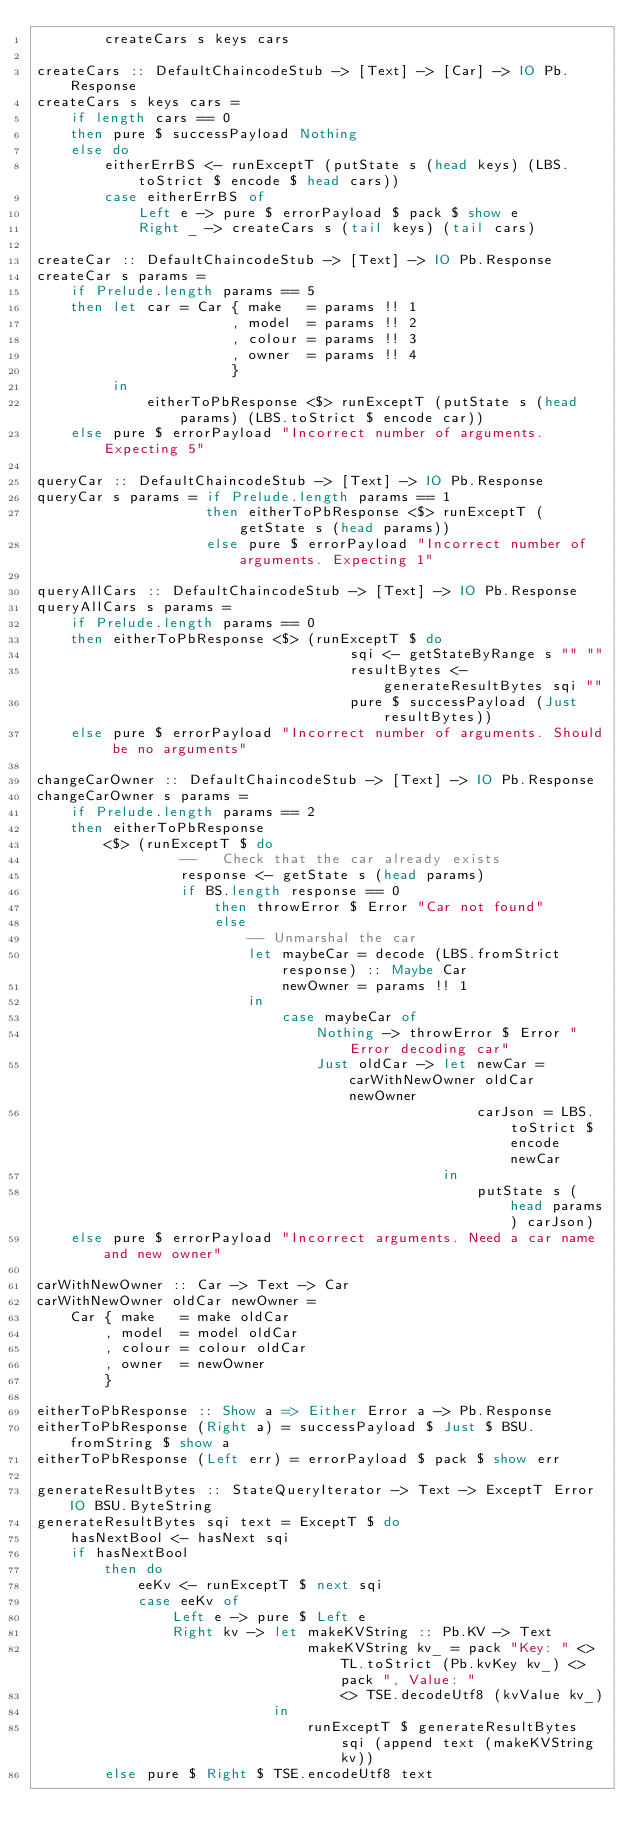Convert code to text. <code><loc_0><loc_0><loc_500><loc_500><_Haskell_>        createCars s keys cars

createCars :: DefaultChaincodeStub -> [Text] -> [Car] -> IO Pb.Response
createCars s keys cars =
    if length cars == 0
    then pure $ successPayload Nothing
    else do
        eitherErrBS <- runExceptT (putState s (head keys) (LBS.toStrict $ encode $ head cars))
        case eitherErrBS of
            Left e -> pure $ errorPayload $ pack $ show e
            Right _ -> createCars s (tail keys) (tail cars)

createCar :: DefaultChaincodeStub -> [Text] -> IO Pb.Response
createCar s params =
    if Prelude.length params == 5
    then let car = Car { make   = params !! 1
                       , model  = params !! 2
                       , colour = params !! 3
                       , owner  = params !! 4
                       }
         in
             eitherToPbResponse <$> runExceptT (putState s (head params) (LBS.toStrict $ encode car))
    else pure $ errorPayload "Incorrect number of arguments. Expecting 5"

queryCar :: DefaultChaincodeStub -> [Text] -> IO Pb.Response
queryCar s params = if Prelude.length params == 1
                    then eitherToPbResponse <$> runExceptT (getState s (head params))
                    else pure $ errorPayload "Incorrect number of arguments. Expecting 1"

queryAllCars :: DefaultChaincodeStub -> [Text] -> IO Pb.Response
queryAllCars s params =
    if Prelude.length params == 0
    then eitherToPbResponse <$> (runExceptT $ do
                                     sqi <- getStateByRange s "" ""
                                     resultBytes <- generateResultBytes sqi ""
                                     pure $ successPayload (Just resultBytes))
    else pure $ errorPayload "Incorrect number of arguments. Should be no arguments"

changeCarOwner :: DefaultChaincodeStub -> [Text] -> IO Pb.Response
changeCarOwner s params =
    if Prelude.length params == 2
    then eitherToPbResponse
        <$> (runExceptT $ do
                 --   Check that the car already exists
                 response <- getState s (head params)
                 if BS.length response == 0
                     then throwError $ Error "Car not found"
                     else 
                         -- Unmarshal the car
                         let maybeCar = decode (LBS.fromStrict response) :: Maybe Car
                             newOwner = params !! 1
                         in
                             case maybeCar of
                                 Nothing -> throwError $ Error "Error decoding car"
                                 Just oldCar -> let newCar = carWithNewOwner oldCar newOwner
                                                    carJson = LBS.toStrict $ encode newCar
                                                in
                                                    putState s (head params) carJson)
    else pure $ errorPayload "Incorrect arguments. Need a car name and new owner"

carWithNewOwner :: Car -> Text -> Car
carWithNewOwner oldCar newOwner =
    Car { make   = make oldCar
        , model  = model oldCar
        , colour = colour oldCar
        , owner  = newOwner
        }

eitherToPbResponse :: Show a => Either Error a -> Pb.Response
eitherToPbResponse (Right a) = successPayload $ Just $ BSU.fromString $ show a
eitherToPbResponse (Left err) = errorPayload $ pack $ show err

generateResultBytes :: StateQueryIterator -> Text -> ExceptT Error IO BSU.ByteString
generateResultBytes sqi text = ExceptT $ do
    hasNextBool <- hasNext sqi
    if hasNextBool
        then do
            eeKv <- runExceptT $ next sqi
            case eeKv of
                Left e -> pure $ Left e
                Right kv -> let makeKVString :: Pb.KV -> Text
                                makeKVString kv_ = pack "Key: " <> TL.toStrict (Pb.kvKey kv_) <> pack ", Value: "
                                    <> TSE.decodeUtf8 (kvValue kv_)
                            in
                                runExceptT $ generateResultBytes sqi (append text (makeKVString kv))
        else pure $ Right $ TSE.encodeUtf8 text</code> 